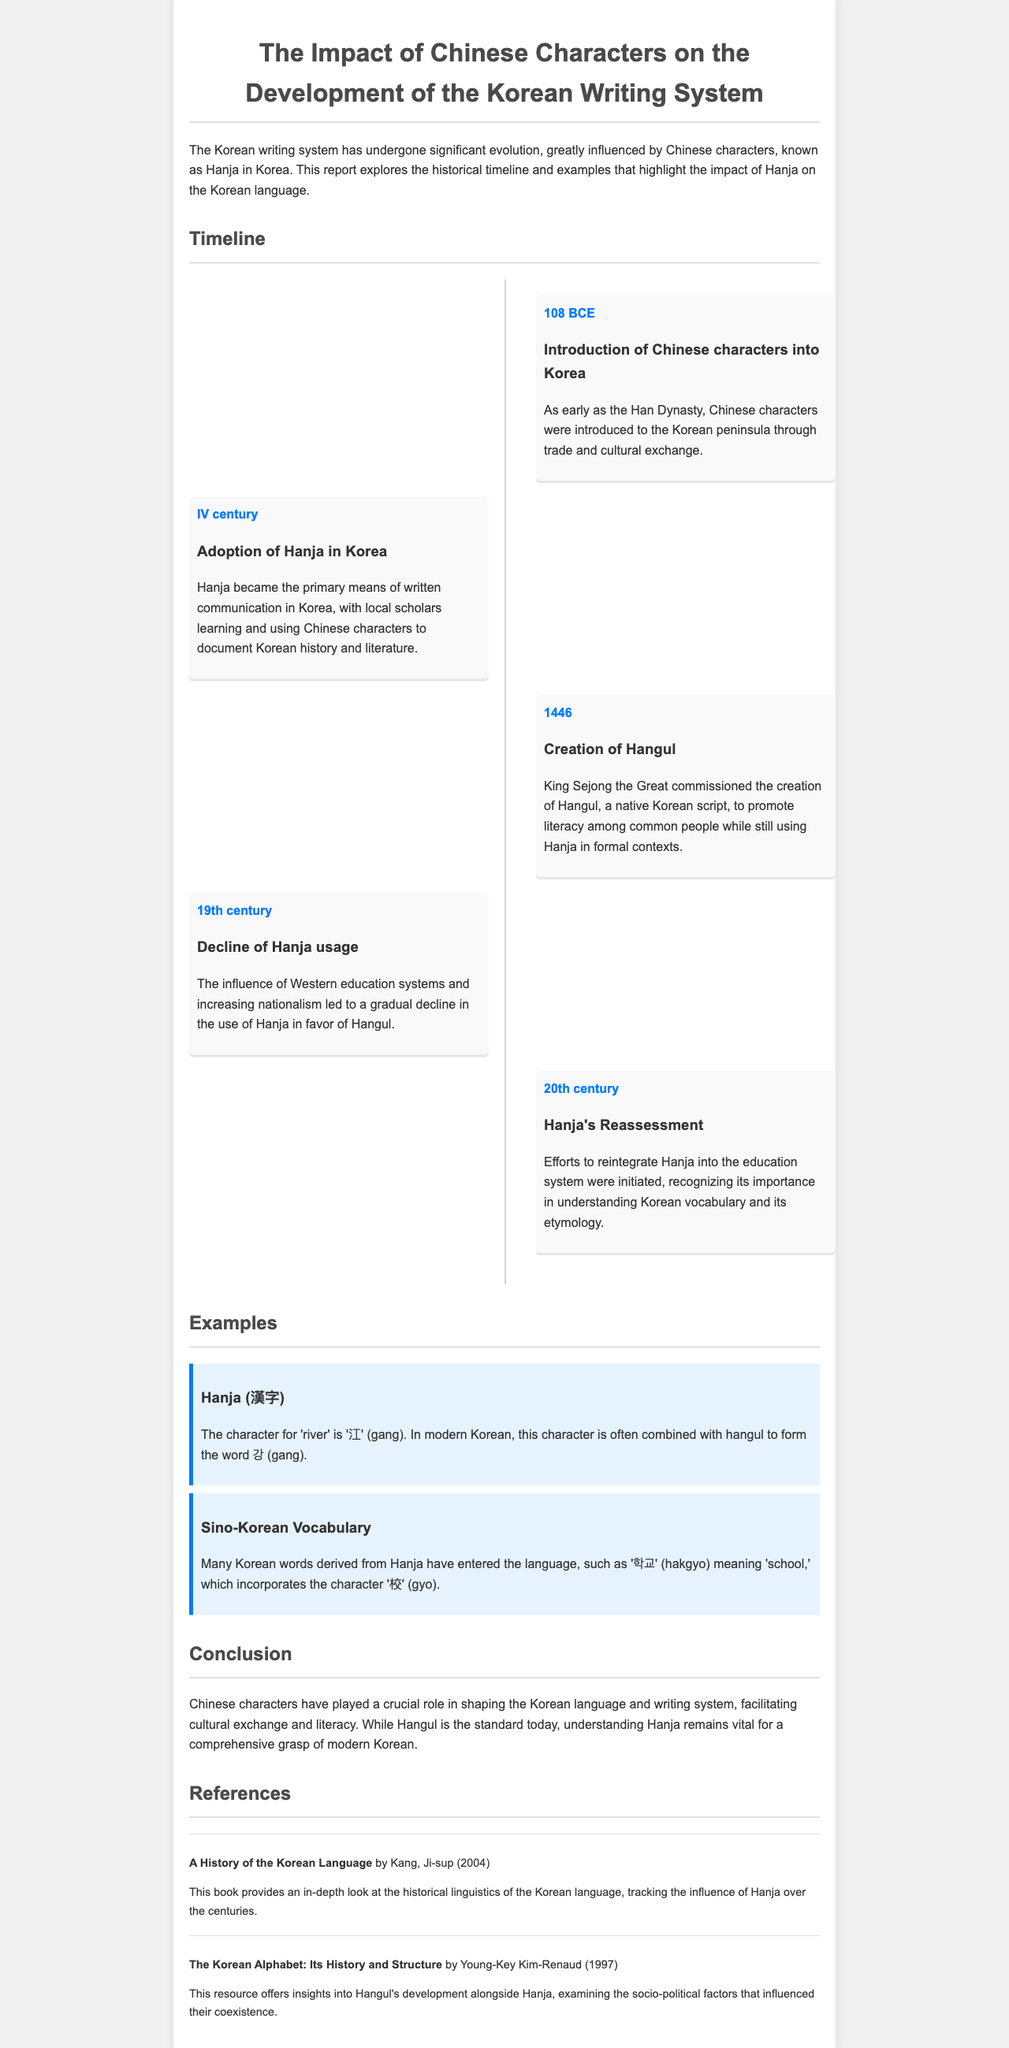What year were Chinese characters introduced into Korea? The document states that Chinese characters were introduced to Korea in 108 BCE.
Answer: 108 BCE What significant event occurred in 1446? The report mentions that King Sejong the Great commissioned the creation of Hangul in this year.
Answer: Creation of Hangul Which character represents 'river' in Hanja? The document states that the character for 'river' is '江' (gang).
Answer: 江 What does the word '학교' (hakgyo) mean? The document explains that '학교' means 'school' and incorporates the character '校' (gyo).
Answer: school What was the primary means of written communication in IV century Korea? According to the document, Hanja became the primary means of written communication.
Answer: Hanja What influence contributed to the decline of Hanja usage in the 19th century? The report notes that the influence of Western education systems contributed to the decline of Hanja.
Answer: Western education What was the primary subject of the report? The report focuses on the impact of Chinese characters on the development of the Korean writing system.
Answer: Chinese characters Who authored "A History of the Korean Language"? The document attributes this book to Kang, Ji-sup, and provides the publication year.
Answer: Kang, Ji-sup What social development promoted the creation of Hangul? The creation of Hangul was commissioned to promote literacy among common people.
Answer: literacy 